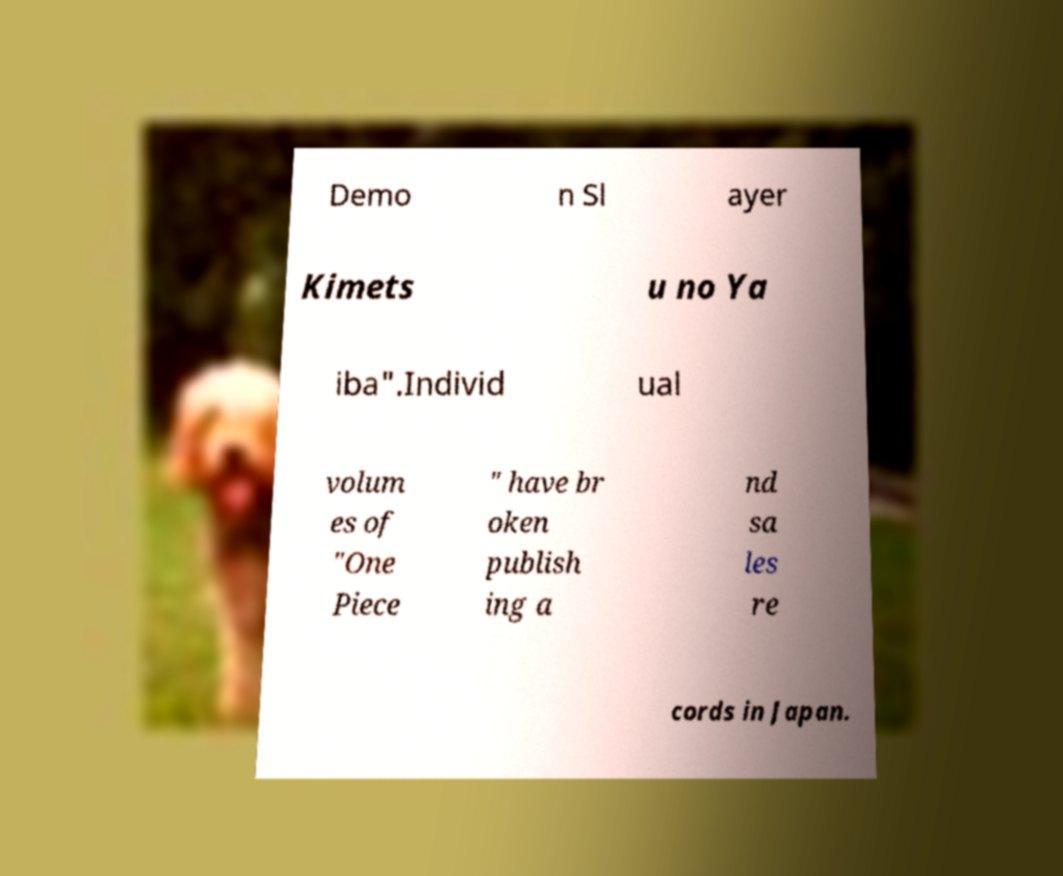There's text embedded in this image that I need extracted. Can you transcribe it verbatim? Demo n Sl ayer Kimets u no Ya iba".Individ ual volum es of "One Piece " have br oken publish ing a nd sa les re cords in Japan. 